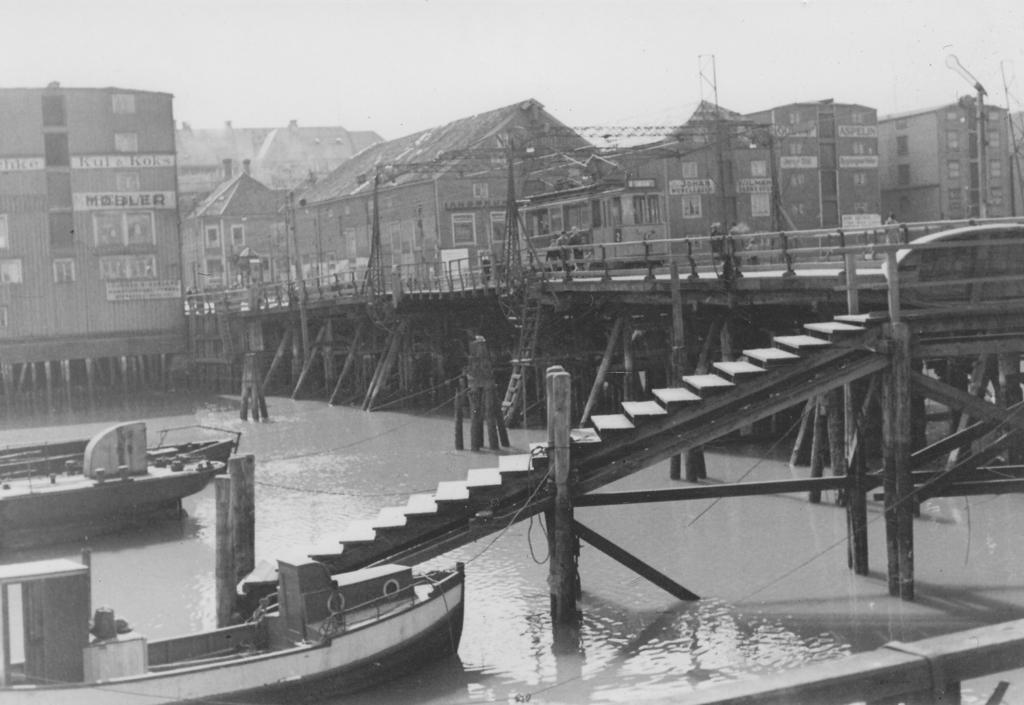What is the color scheme of the image? The image is black and white. What natural element is present in the image? There is water in the image. What man-made objects can be seen in the image? There are boats in the image. What architectural feature is present in the image? There are steps in the image. What can be seen in the background of the image? There are buildings and the sky visible in the background of the image. What type of chess piece is floating on the water in the image? There is no chess piece present in the image; it features water, boats, steps, buildings, and the sky. 